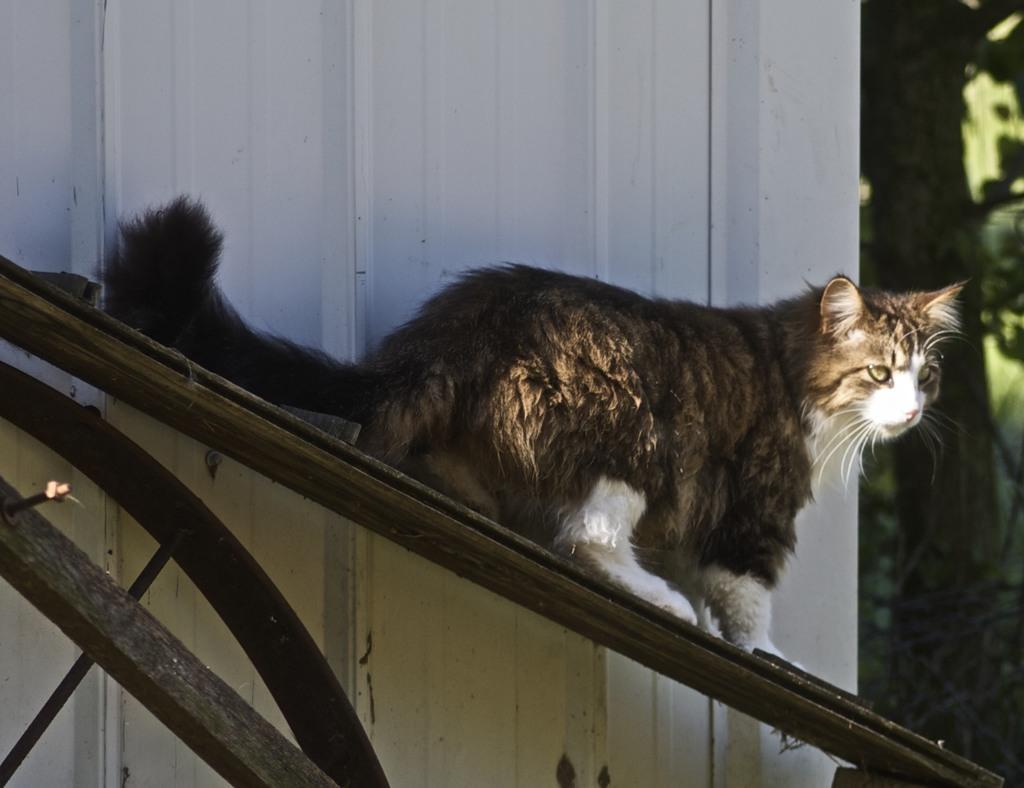In one or two sentences, can you explain what this image depicts? In this image I can see the cat on the wooden object. The cat is in brown, black and white color. I can see the white color object and the green color background. 